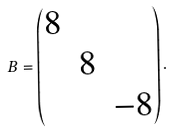Convert formula to latex. <formula><loc_0><loc_0><loc_500><loc_500>B = \begin{pmatrix} 8 \\ & 8 \\ & & - 8 \end{pmatrix} .</formula> 